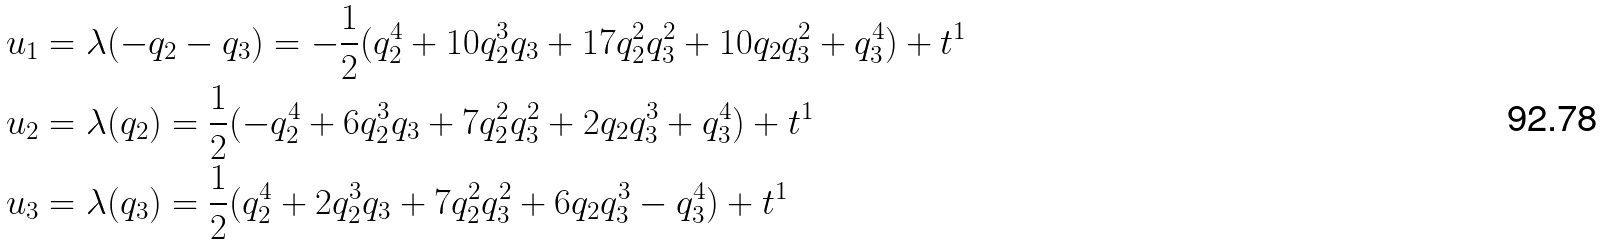<formula> <loc_0><loc_0><loc_500><loc_500>u _ { 1 } & = \lambda ( - q _ { 2 } - q _ { 3 } ) = - \frac { 1 } { 2 } ( q _ { 2 } ^ { 4 } + 1 0 q _ { 2 } ^ { 3 } q _ { 3 } + 1 7 q _ { 2 } ^ { 2 } q _ { 3 } ^ { 2 } + 1 0 q _ { 2 } q _ { 3 } ^ { 2 } + q _ { 3 } ^ { 4 } ) + t ^ { 1 } \\ u _ { 2 } & = \lambda ( q _ { 2 } ) = \frac { 1 } { 2 } ( - q _ { 2 } ^ { 4 } + 6 q _ { 2 } ^ { 3 } q _ { 3 } + 7 q _ { 2 } ^ { 2 } q _ { 3 } ^ { 2 } + 2 q _ { 2 } q _ { 3 } ^ { 3 } + q _ { 3 } ^ { 4 } ) + t ^ { 1 } \\ u _ { 3 } & = \lambda ( q _ { 3 } ) = \frac { 1 } { 2 } ( q _ { 2 } ^ { 4 } + 2 q _ { 2 } ^ { 3 } q _ { 3 } + 7 q _ { 2 } ^ { 2 } q _ { 3 } ^ { 2 } + 6 q _ { 2 } q _ { 3 } ^ { 3 } - q _ { 3 } ^ { 4 } ) + t ^ { 1 }</formula> 